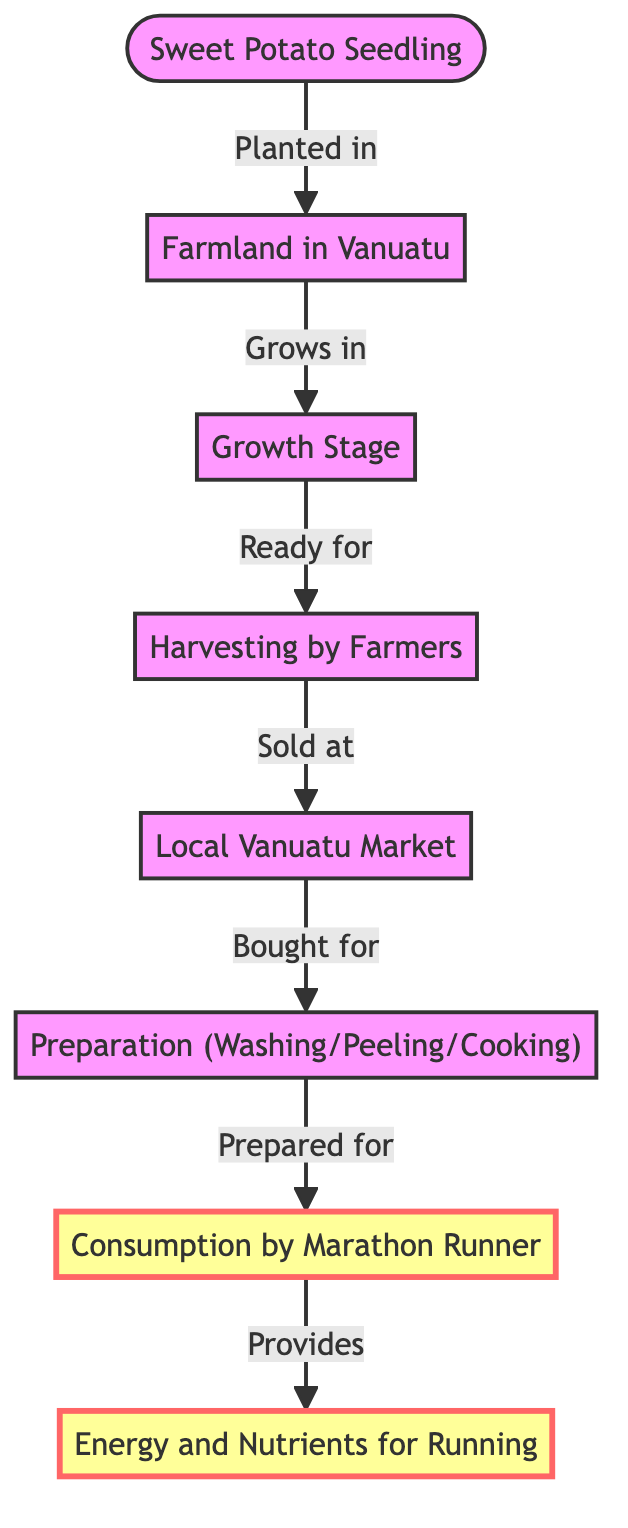What is the first step in the journey of a sweet potato? The first step is indicated in the diagram by the node titled "Sweet Potato Seedling," which is where the journey begins when the seedling is planted in the farmland.
Answer: Sweet Potato Seedling How many nodes are there in the diagram? Counting each individual node shown in the diagram, there are a total of six nodes represented: Sweet Potato Seedling, Farmland in Vanuatu, Growth Stage, Harvesting by Farmers, Local Vanuatu Market, Preparation, Consumption by Marathon Runner, and Nutrient Benefit. The total count is seven nodes.
Answer: Seven What stage comes after harvesting? The flow from the node "Harvesting by Farmers" leads to the next node titled "Local Vanuatu Market," indicating that this is the immediate next stage after harvesting.
Answer: Local Vanuatu Market Which node highlights consumption? The diagram highlights the "Consumption by Marathon Runner" node along with the "Nutrient Benefit," as indicated by the specific styling applied to these nodes, which emphasizes their importance in the food chain.
Answer: Consumption by Marathon Runner What provides energy and nutrients for running? The diagram concludes with the node "Nutrient Benefit," which is provided as a result of the "Consumption by Marathon Runner." This indicates that the nutrient benefit specifically relates to energy and nutrients acquired through the consumption of sweet potatoes.
Answer: Nutrient Benefit What is cultivated in farmland in Vanuatu? The diagram starts with the "Sweet Potato Seedling," which is planted in farmland, indicating that sweet potatoes are what are cultivated in Vanuatu's farmland.
Answer: Sweet Potato What is the final outcome of the journey? The final outcome depicted in the diagram is represented by the node "Nutrient Benefit," which signifies what is gained from consuming sweet potatoes, specifically for activities like running.
Answer: Nutrient Benefit How does sweet potato move from the farmer to the consumer? The flow indicates that after "Harvesting by Farmers," sweet potatoes are sold at the "Local Vanuatu Market," and from there, they are bought for "Preparation," which leads to "Consumption by Marathon Runner." This outlines that the movement is from harvesting to market sale, then to preparation, and ultimately to consumption.
Answer: Local Vanuatu Market 